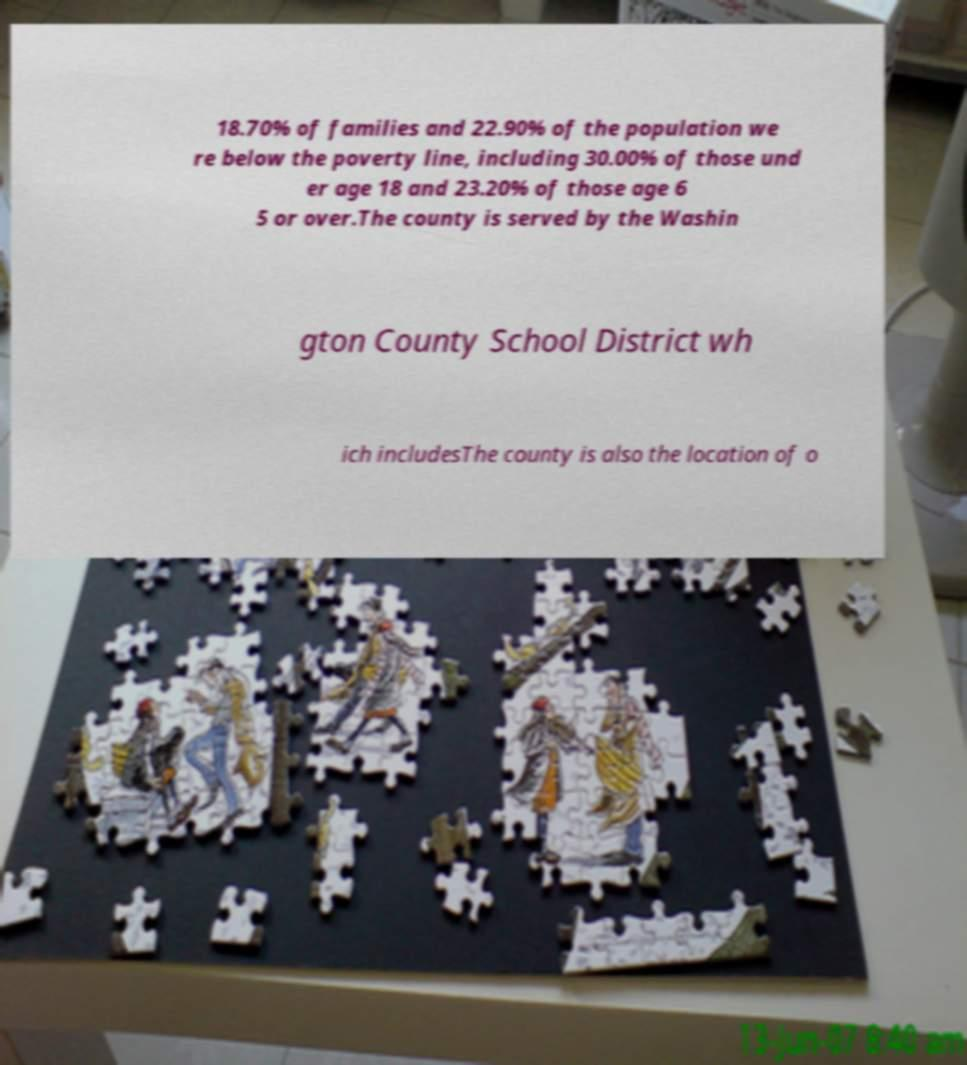Could you extract and type out the text from this image? 18.70% of families and 22.90% of the population we re below the poverty line, including 30.00% of those und er age 18 and 23.20% of those age 6 5 or over.The county is served by the Washin gton County School District wh ich includesThe county is also the location of o 